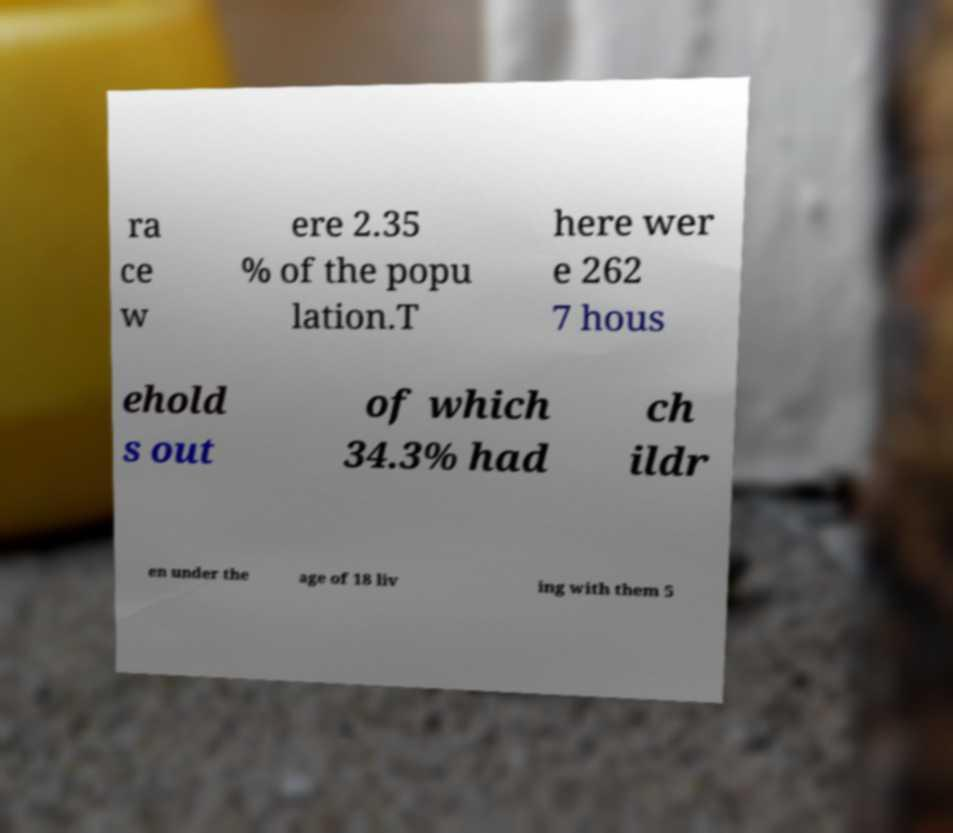There's text embedded in this image that I need extracted. Can you transcribe it verbatim? ra ce w ere 2.35 % of the popu lation.T here wer e 262 7 hous ehold s out of which 34.3% had ch ildr en under the age of 18 liv ing with them 5 